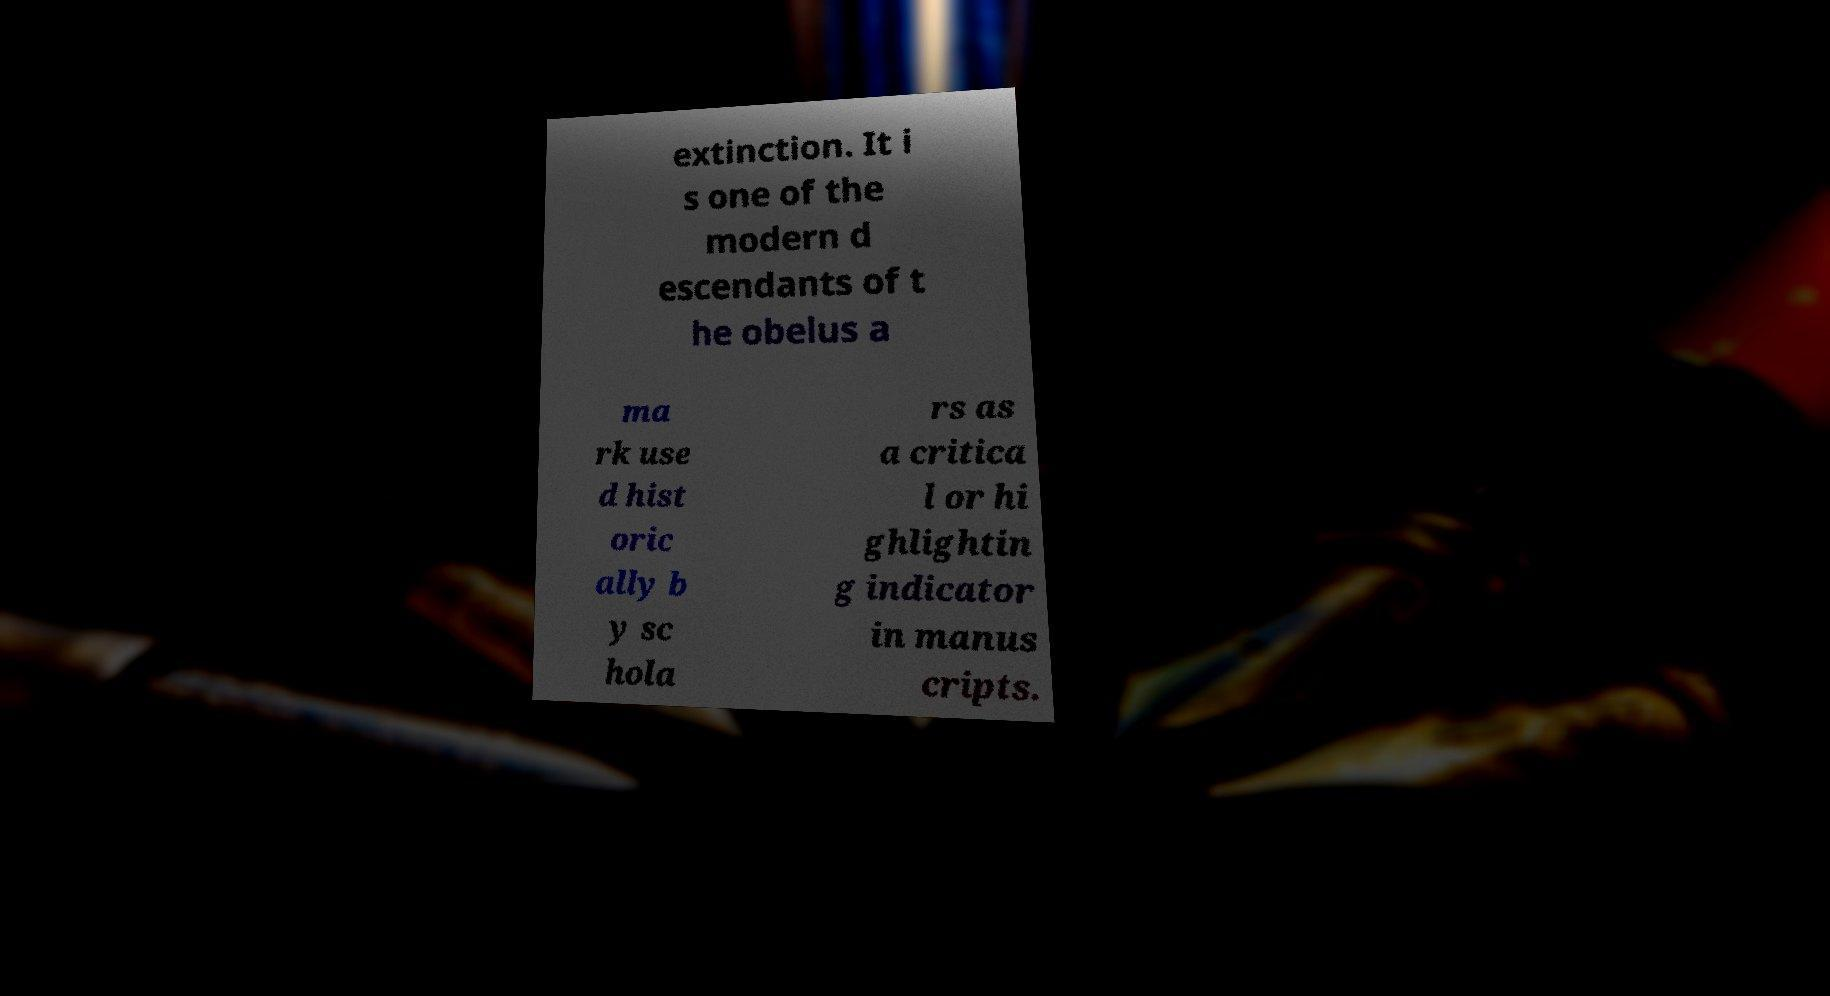Can you read and provide the text displayed in the image?This photo seems to have some interesting text. Can you extract and type it out for me? extinction. It i s one of the modern d escendants of t he obelus a ma rk use d hist oric ally b y sc hola rs as a critica l or hi ghlightin g indicator in manus cripts. 